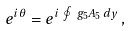Convert formula to latex. <formula><loc_0><loc_0><loc_500><loc_500>e ^ { i \theta } = e ^ { i \, \oint \, g _ { 5 } A _ { 5 } \, d y } \, ,</formula> 